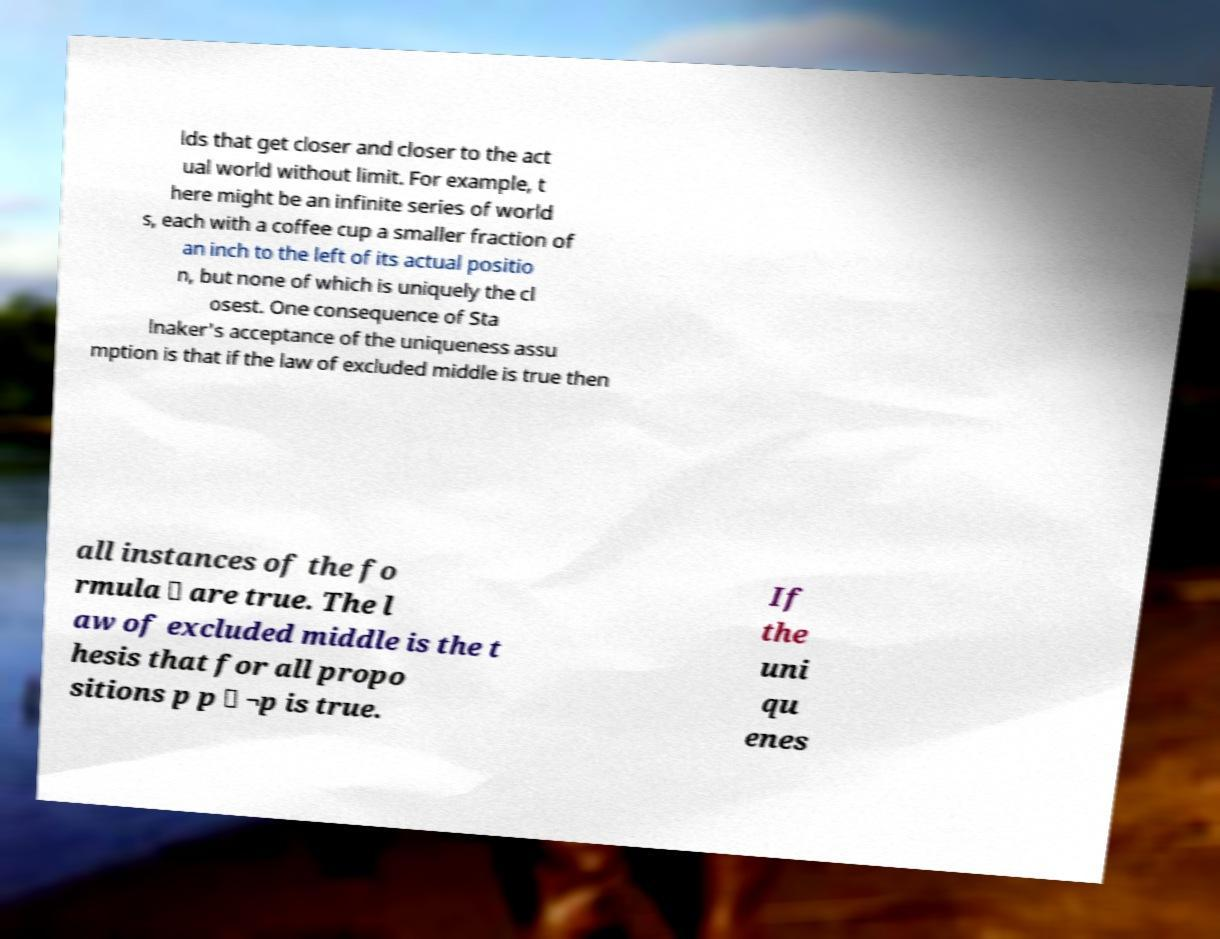What messages or text are displayed in this image? I need them in a readable, typed format. lds that get closer and closer to the act ual world without limit. For example, t here might be an infinite series of world s, each with a coffee cup a smaller fraction of an inch to the left of its actual positio n, but none of which is uniquely the cl osest. One consequence of Sta lnaker's acceptance of the uniqueness assu mption is that if the law of excluded middle is true then all instances of the fo rmula ∨ are true. The l aw of excluded middle is the t hesis that for all propo sitions p p ∨ ¬p is true. If the uni qu enes 